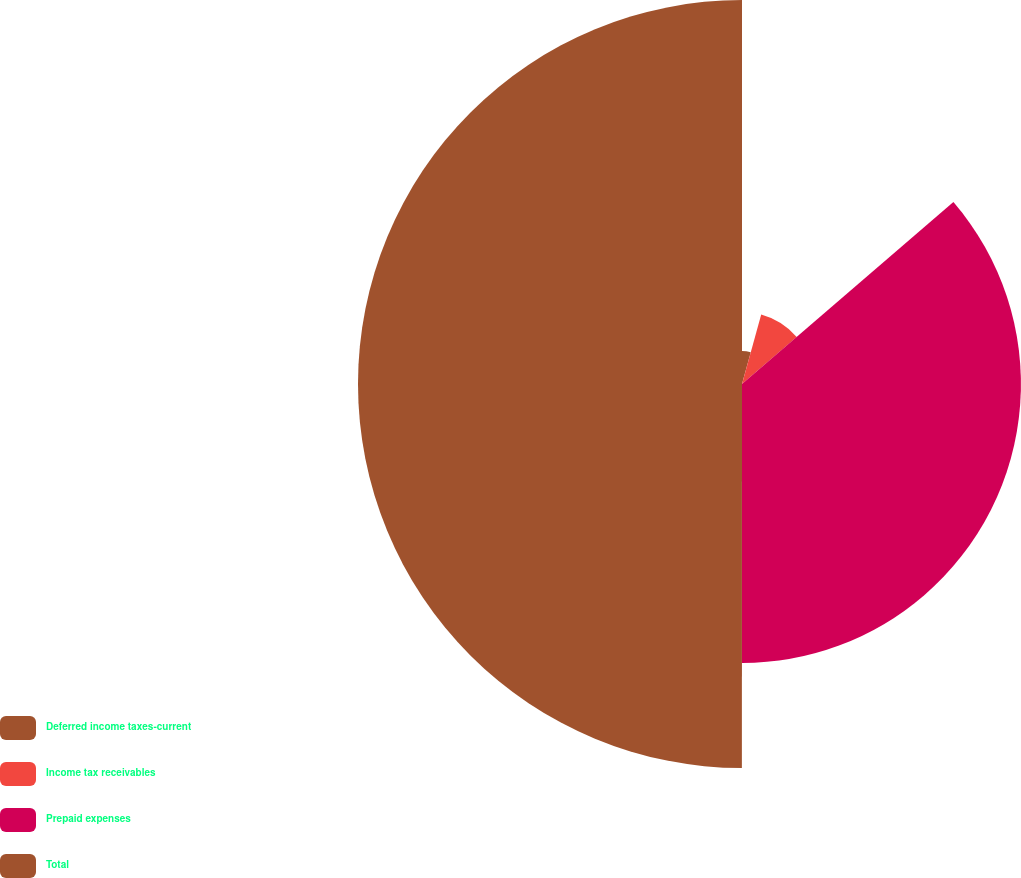Convert chart to OTSL. <chart><loc_0><loc_0><loc_500><loc_500><pie_chart><fcel>Deferred income taxes-current<fcel>Income tax receivables<fcel>Prepaid expenses<fcel>Total<nl><fcel>4.29%<fcel>9.4%<fcel>36.32%<fcel>50.0%<nl></chart> 